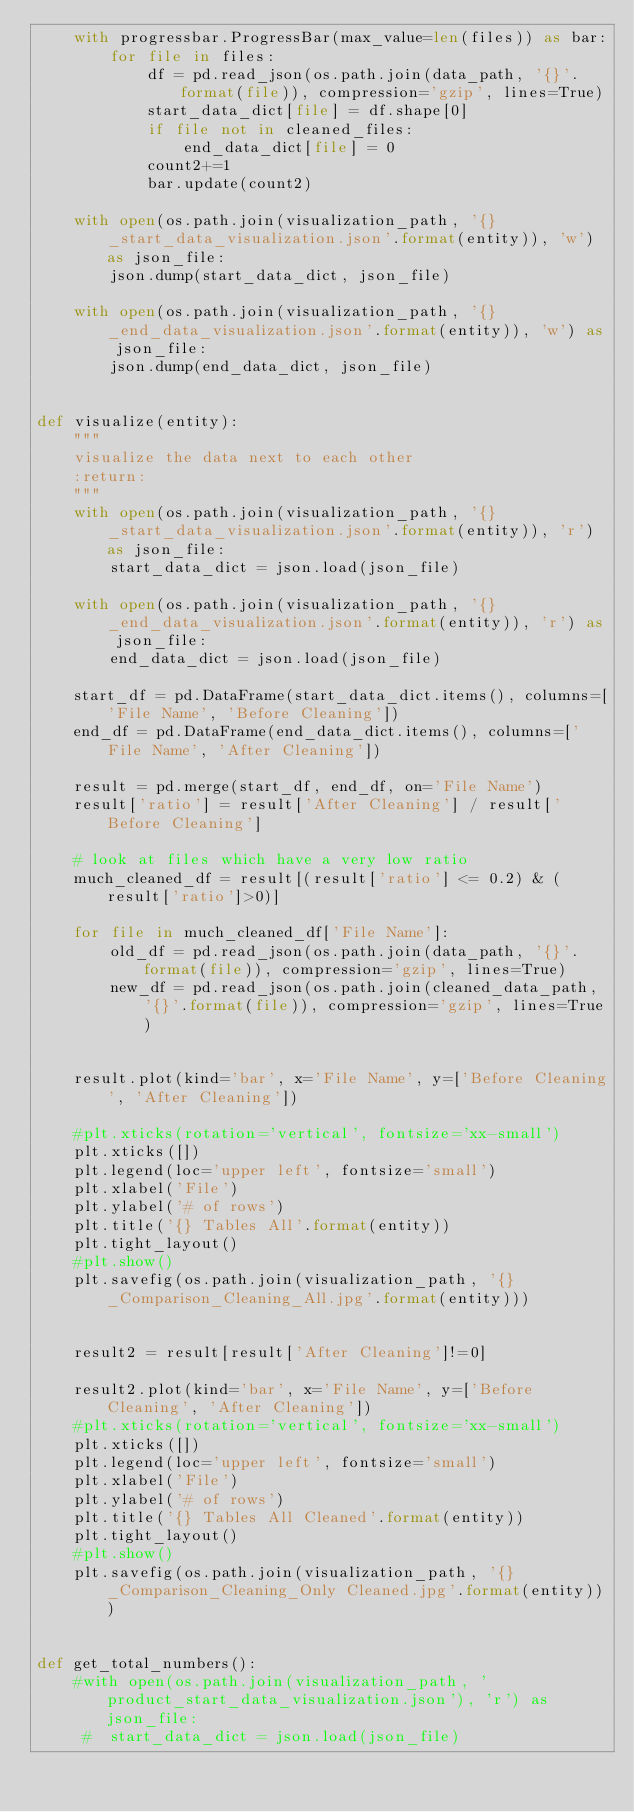Convert code to text. <code><loc_0><loc_0><loc_500><loc_500><_Python_>    with progressbar.ProgressBar(max_value=len(files)) as bar:
        for file in files:
            df = pd.read_json(os.path.join(data_path, '{}'.format(file)), compression='gzip', lines=True)
            start_data_dict[file] = df.shape[0]
            if file not in cleaned_files:
                end_data_dict[file] = 0
            count2+=1
            bar.update(count2)

    with open(os.path.join(visualization_path, '{}_start_data_visualization.json'.format(entity)), 'w') as json_file:
        json.dump(start_data_dict, json_file)

    with open(os.path.join(visualization_path, '{}_end_data_visualization.json'.format(entity)), 'w') as json_file:
        json.dump(end_data_dict, json_file)


def visualize(entity):
    """
    visualize the data next to each other
    :return:
    """
    with open(os.path.join(visualization_path, '{}_start_data_visualization.json'.format(entity)), 'r') as json_file:
        start_data_dict = json.load(json_file)

    with open(os.path.join(visualization_path, '{}_end_data_visualization.json'.format(entity)), 'r') as json_file:
        end_data_dict = json.load(json_file)

    start_df = pd.DataFrame(start_data_dict.items(), columns=['File Name', 'Before Cleaning'])
    end_df = pd.DataFrame(end_data_dict.items(), columns=['File Name', 'After Cleaning'])

    result = pd.merge(start_df, end_df, on='File Name')
    result['ratio'] = result['After Cleaning'] / result['Before Cleaning']

    # look at files which have a very low ratio
    much_cleaned_df = result[(result['ratio'] <= 0.2) & (result['ratio']>0)]

    for file in much_cleaned_df['File Name']:
        old_df = pd.read_json(os.path.join(data_path, '{}'.format(file)), compression='gzip', lines=True)
        new_df = pd.read_json(os.path.join(cleaned_data_path, '{}'.format(file)), compression='gzip', lines=True)


    result.plot(kind='bar', x='File Name', y=['Before Cleaning', 'After Cleaning'])

    #plt.xticks(rotation='vertical', fontsize='xx-small')
    plt.xticks([])
    plt.legend(loc='upper left', fontsize='small')
    plt.xlabel('File')
    plt.ylabel('# of rows')
    plt.title('{} Tables All'.format(entity))
    plt.tight_layout()
    #plt.show()
    plt.savefig(os.path.join(visualization_path, '{}_Comparison_Cleaning_All.jpg'.format(entity)))


    result2 = result[result['After Cleaning']!=0]

    result2.plot(kind='bar', x='File Name', y=['Before Cleaning', 'After Cleaning'])
    #plt.xticks(rotation='vertical', fontsize='xx-small')
    plt.xticks([])
    plt.legend(loc='upper left', fontsize='small')
    plt.xlabel('File')
    plt.ylabel('# of rows')
    plt.title('{} Tables All Cleaned'.format(entity))
    plt.tight_layout()
    #plt.show()
    plt.savefig(os.path.join(visualization_path, '{}_Comparison_Cleaning_Only Cleaned.jpg'.format(entity)))


def get_total_numbers():
    #with open(os.path.join(visualization_path, 'product_start_data_visualization.json'), 'r') as json_file:
     #  start_data_dict = json.load(json_file)
</code> 